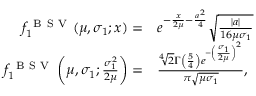Convert formula to latex. <formula><loc_0><loc_0><loc_500><loc_500>\begin{array} { r l } { f _ { 1 } ^ { B S V } ( \mu , \sigma _ { 1 } ; x ) = } & e ^ { - \frac { x } { 2 \mu } - \frac { a ^ { 2 } } 4 } \sqrt { \frac { | a | } { 1 6 \mu \sigma _ { 1 } } } } \\ { f _ { 1 } ^ { B S V } \left ( \mu , \sigma _ { 1 } ; \frac { \sigma _ { 1 } ^ { 2 } } { 2 \mu } \right ) = } & \frac { \sqrt { [ } 4 ] { 2 } \Gamma \left ( \frac { 5 } { 4 } \right ) e ^ { - \left ( \frac { \sigma _ { 1 } } { 2 \mu } \right ) ^ { 2 } } } { \pi \sqrt { \mu \sigma _ { 1 } } } , } \end{array}</formula> 